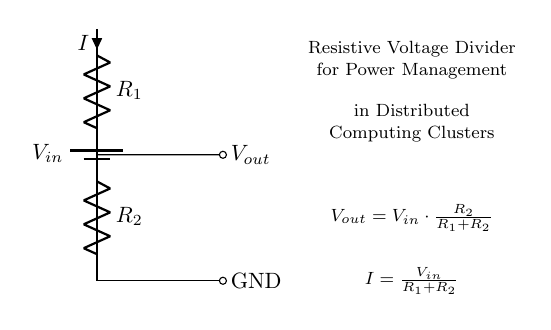What is the input voltage labeled in the circuit? The input voltage is labeled as \( V_{in} \) in the circuit diagram, located at the battery symbol.
Answer: \( V_{in} \) What components are used in this voltage divider? The components in the voltage divider include two resistors labeled \( R_1 \) and \( R_2 \), and a battery representing the input voltage labeled \( V_{in} \).
Answer: \( R_1, R_2, V_{in} \) What is the equation for \( V_{out} \) represented in the diagram? The equation for the output voltage \( V_{out} \) is represented as \( V_{out} = V_{in} \cdot \frac{R_2}{R_1 + R_2} \), which describes how the output voltage depends on the input voltage and the resistances.
Answer: \( V_{out} = V_{in} \cdot \frac{R_2}{R_1 + R_2} \) What is the expression for the current \( I \) flowing through the resistors? The expression for the current \( I \) is given as \( I = \frac{V_{in}}{R_1 + R_2} \), indicating the total current based on the input voltage and the total resistance.
Answer: \( I = \frac{V_{in}}{R_1 + R_2} \) How does increasing \( R_2 \) affect \( V_{out} \)? Increasing \( R_2 \) increases \( V_{out} \) because according to the voltage divider formula, a larger \( R_2 \) leads to a larger fraction of \( V_{in} \) being dropped across \( R_2 \).
Answer: Increases \( V_{out} \) Why is the ground point marked in the circuit? The ground point serves as the reference point for voltage measurements and completes the circuit, ensuring that all voltage values are relative to this point, which is essential for circuit operation.
Answer: Reference point 